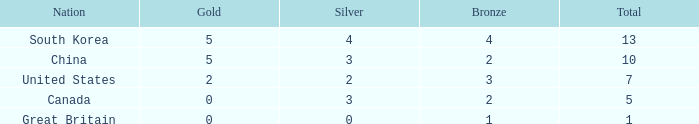What is the average Silver, when Rank is 5, and when Bronze is less than 1? None. 